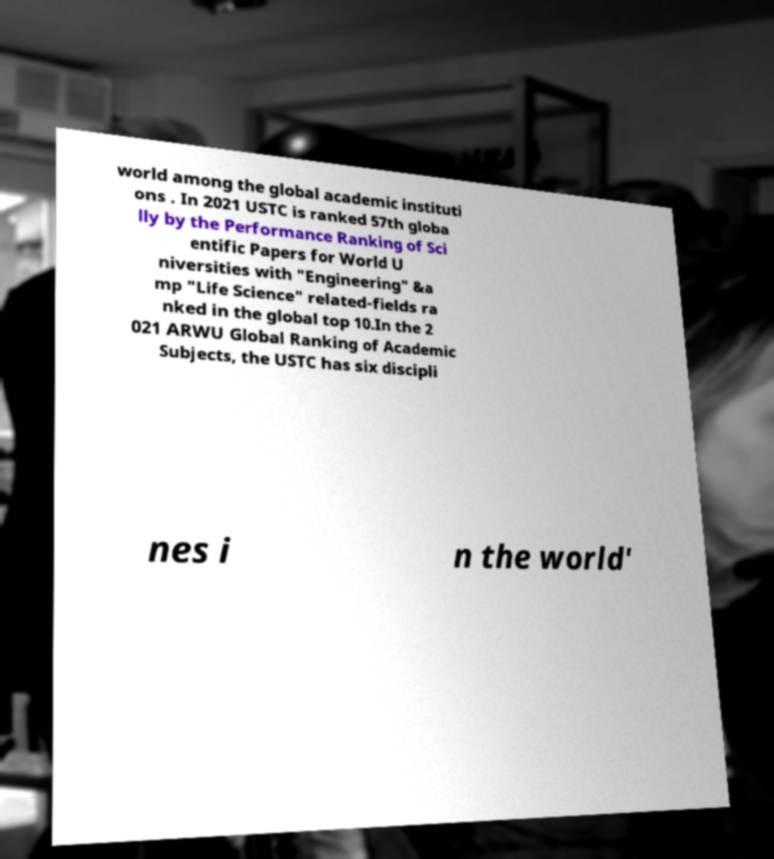Please identify and transcribe the text found in this image. world among the global academic instituti ons . In 2021 USTC is ranked 57th globa lly by the Performance Ranking of Sci entific Papers for World U niversities with "Engineering" &a mp "Life Science" related-fields ra nked in the global top 10.In the 2 021 ARWU Global Ranking of Academic Subjects, the USTC has six discipli nes i n the world' 